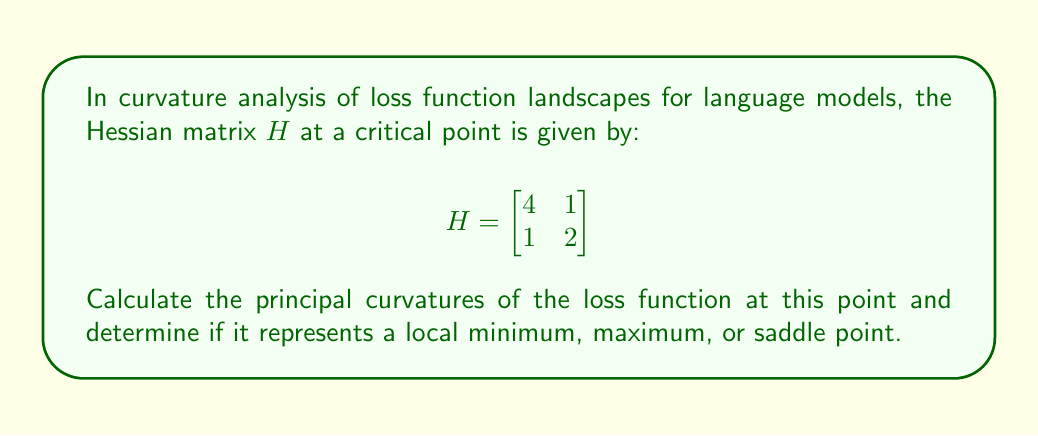Give your solution to this math problem. To analyze the curvature and determine the nature of the critical point, we need to follow these steps:

1. Calculate the eigenvalues of the Hessian matrix:
   The characteristic equation is:
   $$\det(H - \lambda I) = \begin{vmatrix}
   4-\lambda & 1 \\
   1 & 2-\lambda
   \end{vmatrix} = 0$$
   
   $$(4-\lambda)(2-\lambda) - 1 = 0$$
   $$\lambda^2 - 6\lambda + 7 = 0$$

2. Solve the quadratic equation:
   Using the quadratic formula: $\lambda = \frac{-b \pm \sqrt{b^2 - 4ac}}{2a}$
   
   $$\lambda = \frac{6 \pm \sqrt{36 - 28}}{2} = \frac{6 \pm \sqrt{8}}{2} = \frac{6 \pm 2\sqrt{2}}{2}$$

3. The eigenvalues are:
   $$\lambda_1 = 3 + \sqrt{2}$$
   $$\lambda_2 = 3 - \sqrt{2}$$

4. Interpret the results:
   - The eigenvalues of the Hessian matrix represent the principal curvatures of the loss function at the critical point.
   - Both eigenvalues are positive, indicating positive curvature in all directions.
   - Positive curvature in all directions means the critical point is a local minimum.
Answer: Principal curvatures: $3 + \sqrt{2}$ and $3 - \sqrt{2}$; Local minimum 